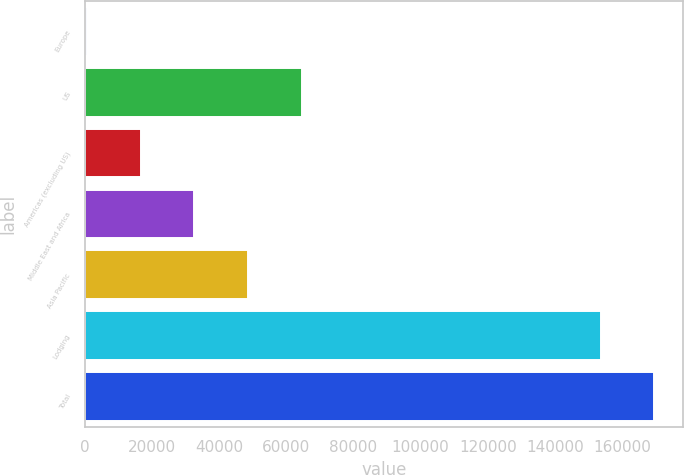<chart> <loc_0><loc_0><loc_500><loc_500><bar_chart><fcel>Europe<fcel>US<fcel>Americas (excluding US)<fcel>Middle East and Africa<fcel>Asia Pacific<fcel>Lodging<fcel>Total<nl><fcel>705<fcel>64594.2<fcel>16677.3<fcel>32649.6<fcel>48621.9<fcel>153634<fcel>169606<nl></chart> 